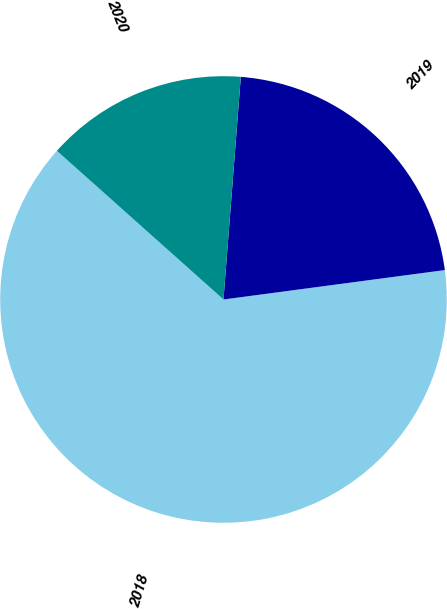<chart> <loc_0><loc_0><loc_500><loc_500><pie_chart><fcel>2018<fcel>2019<fcel>2020<nl><fcel>63.7%<fcel>21.66%<fcel>14.64%<nl></chart> 